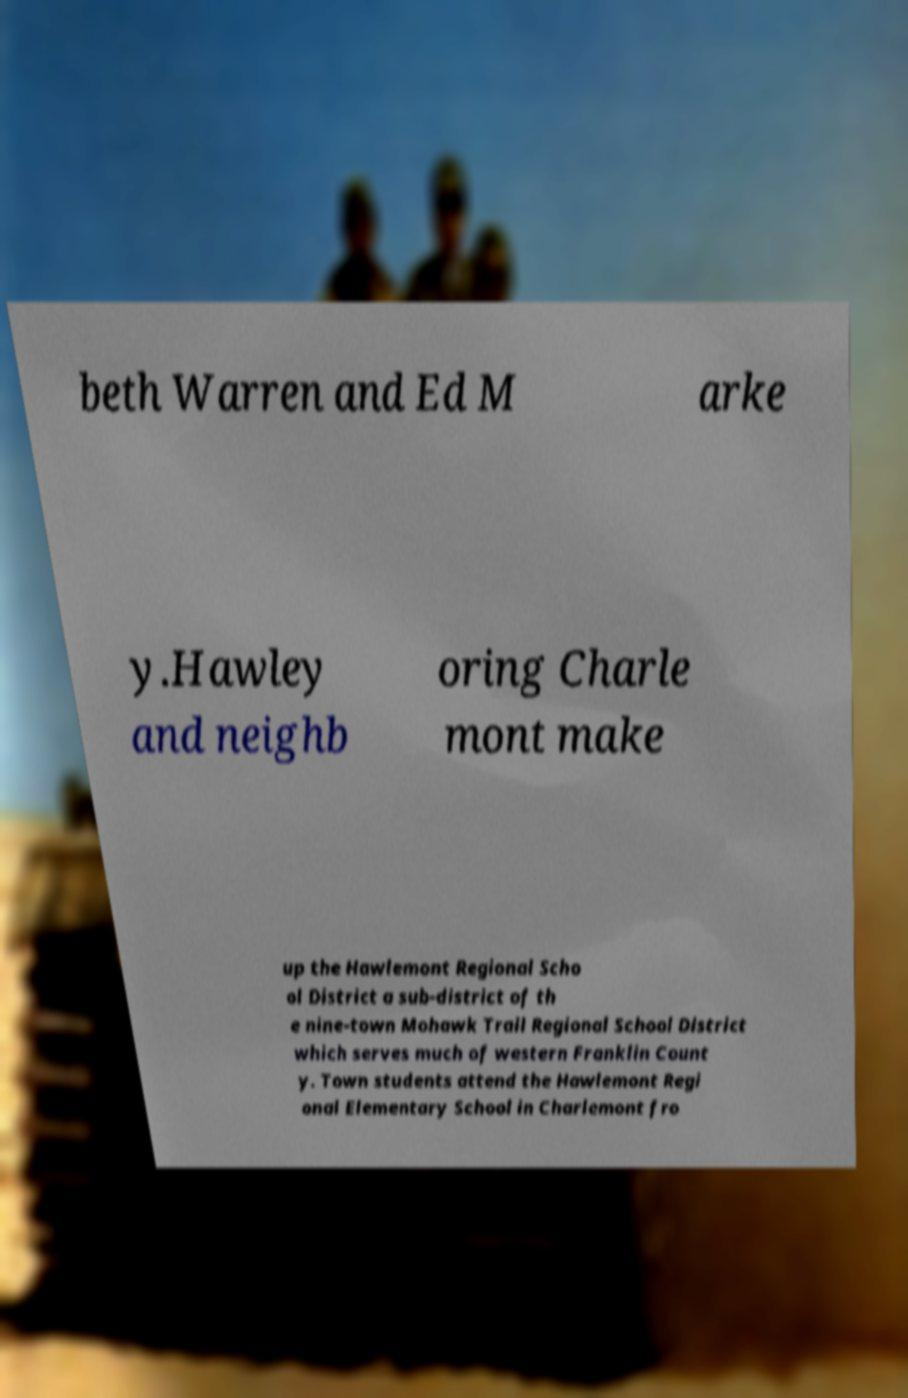There's text embedded in this image that I need extracted. Can you transcribe it verbatim? beth Warren and Ed M arke y.Hawley and neighb oring Charle mont make up the Hawlemont Regional Scho ol District a sub-district of th e nine-town Mohawk Trail Regional School District which serves much of western Franklin Count y. Town students attend the Hawlemont Regi onal Elementary School in Charlemont fro 